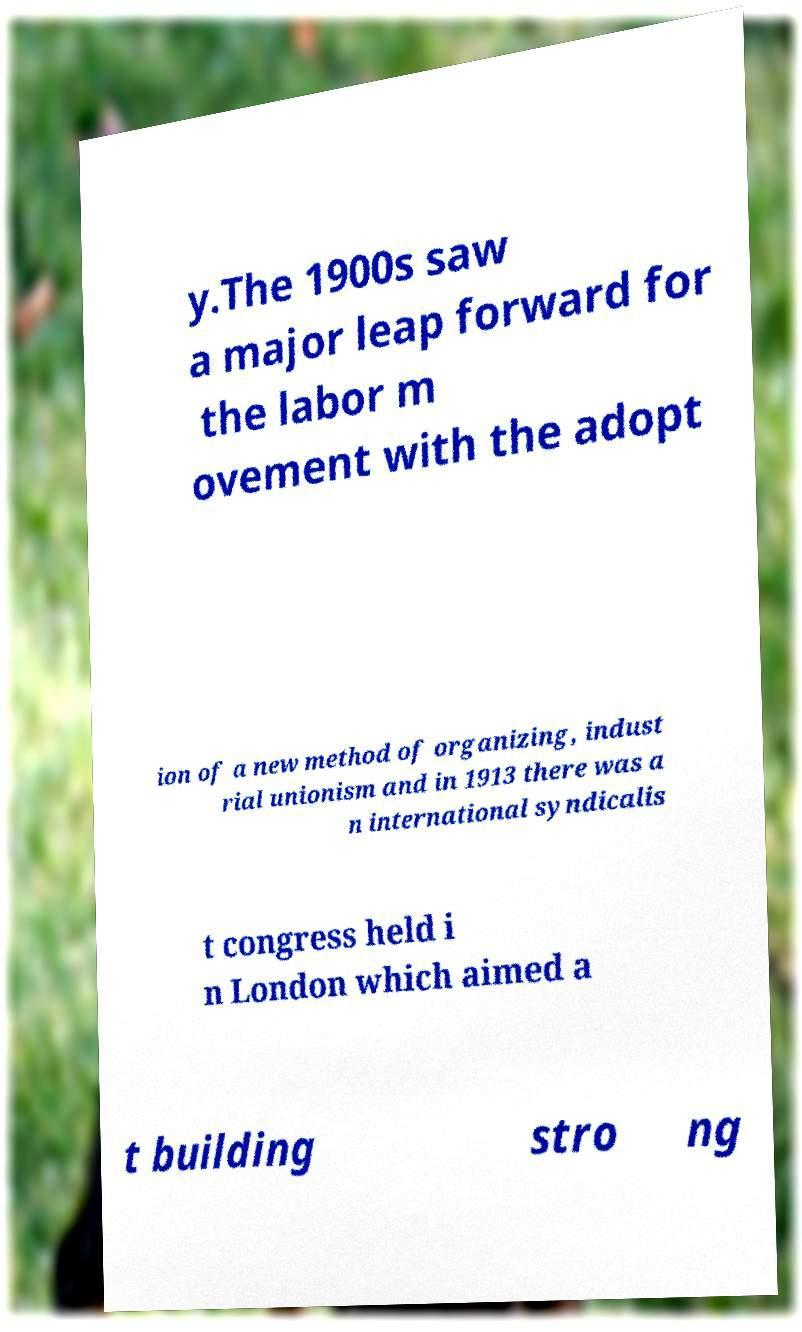Can you accurately transcribe the text from the provided image for me? y.The 1900s saw a major leap forward for the labor m ovement with the adopt ion of a new method of organizing, indust rial unionism and in 1913 there was a n international syndicalis t congress held i n London which aimed a t building stro ng 